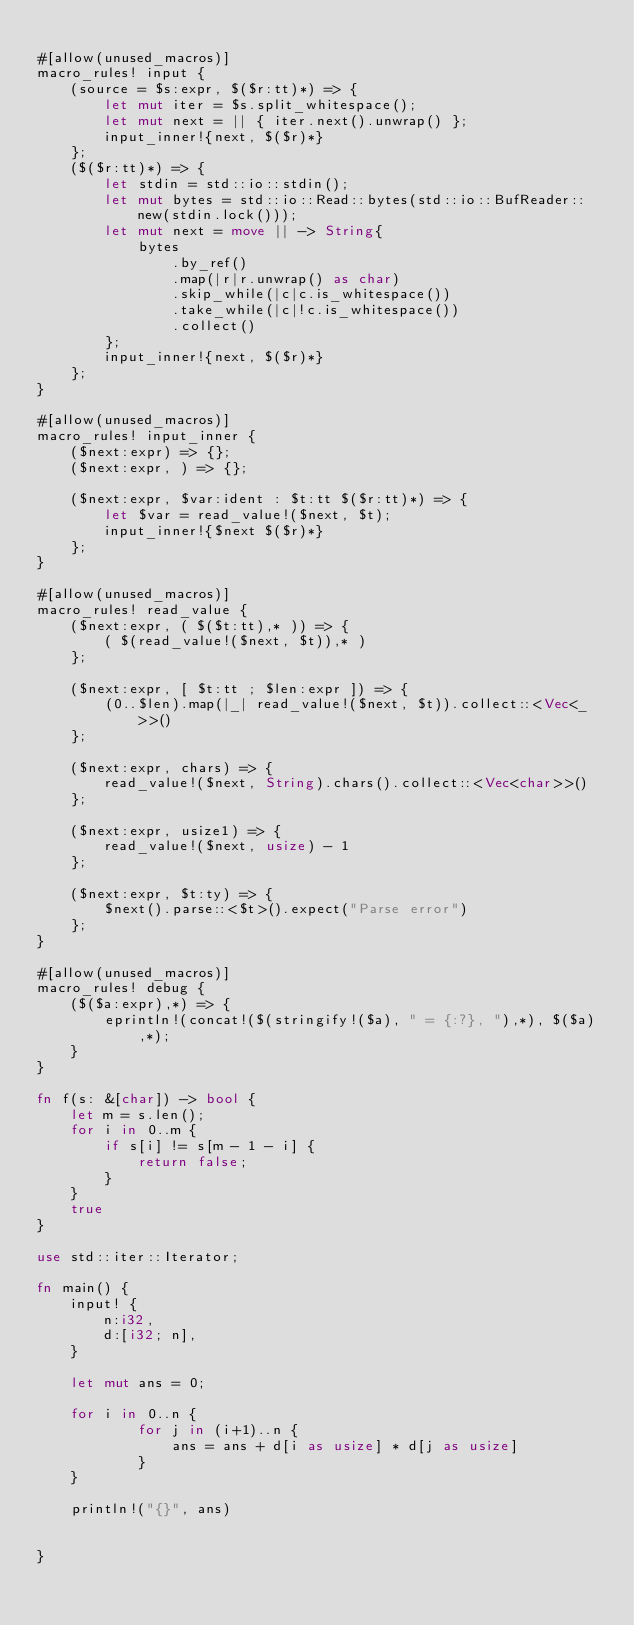<code> <loc_0><loc_0><loc_500><loc_500><_Rust_>
#[allow(unused_macros)]
macro_rules! input {
    (source = $s:expr, $($r:tt)*) => {
        let mut iter = $s.split_whitespace();
        let mut next = || { iter.next().unwrap() };
        input_inner!{next, $($r)*}
    };
    ($($r:tt)*) => {
        let stdin = std::io::stdin();
        let mut bytes = std::io::Read::bytes(std::io::BufReader::new(stdin.lock()));
        let mut next = move || -> String{
            bytes
                .by_ref()
                .map(|r|r.unwrap() as char)
                .skip_while(|c|c.is_whitespace())
                .take_while(|c|!c.is_whitespace())
                .collect()
        };
        input_inner!{next, $($r)*}
    };
}

#[allow(unused_macros)]
macro_rules! input_inner {
    ($next:expr) => {};
    ($next:expr, ) => {};

    ($next:expr, $var:ident : $t:tt $($r:tt)*) => {
        let $var = read_value!($next, $t);
        input_inner!{$next $($r)*}
    };
}

#[allow(unused_macros)]
macro_rules! read_value {
    ($next:expr, ( $($t:tt),* )) => {
        ( $(read_value!($next, $t)),* )
    };

    ($next:expr, [ $t:tt ; $len:expr ]) => {
        (0..$len).map(|_| read_value!($next, $t)).collect::<Vec<_>>()
    };

    ($next:expr, chars) => {
        read_value!($next, String).chars().collect::<Vec<char>>()
    };

    ($next:expr, usize1) => {
        read_value!($next, usize) - 1
    };

    ($next:expr, $t:ty) => {
        $next().parse::<$t>().expect("Parse error")
    };
}

#[allow(unused_macros)]
macro_rules! debug {
    ($($a:expr),*) => {
        eprintln!(concat!($(stringify!($a), " = {:?}, "),*), $($a),*);
    }
}

fn f(s: &[char]) -> bool {
    let m = s.len();
    for i in 0..m {
        if s[i] != s[m - 1 - i] {
            return false;
        }
    }
    true
}

use std::iter::Iterator;

fn main() {
    input! {
        n:i32,
        d:[i32; n],
    }

    let mut ans = 0;

    for i in 0..n {
            for j in (i+1)..n {
                ans = ans + d[i as usize] * d[j as usize]
            }
    }

    println!("{}", ans)
   

}
</code> 